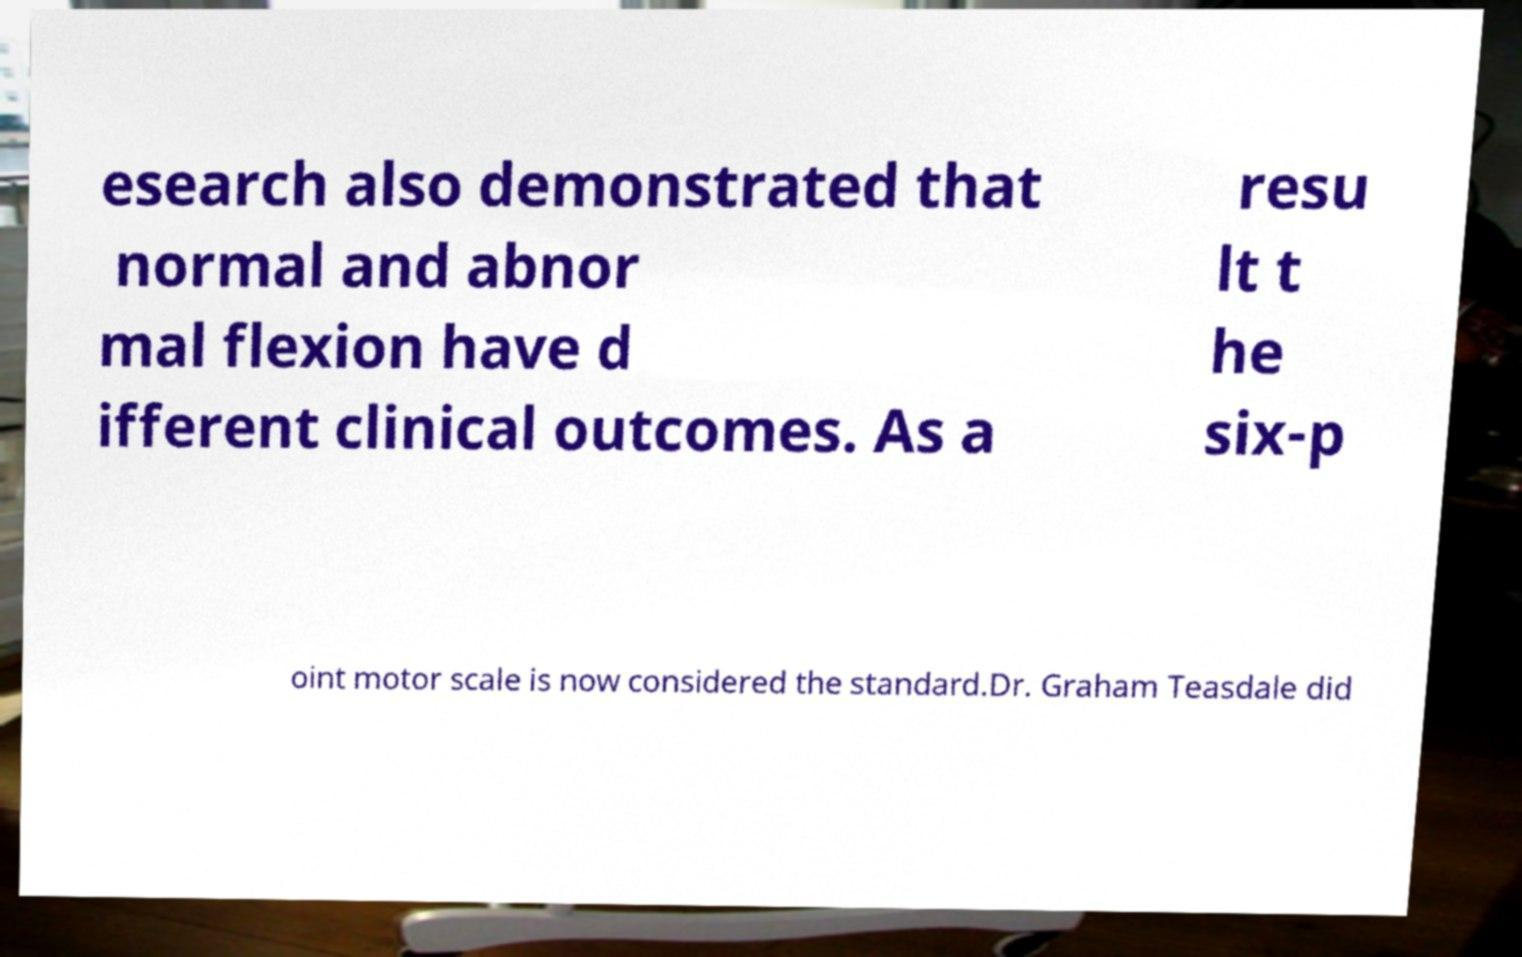Can you accurately transcribe the text from the provided image for me? esearch also demonstrated that normal and abnor mal flexion have d ifferent clinical outcomes. As a resu lt t he six-p oint motor scale is now considered the standard.Dr. Graham Teasdale did 